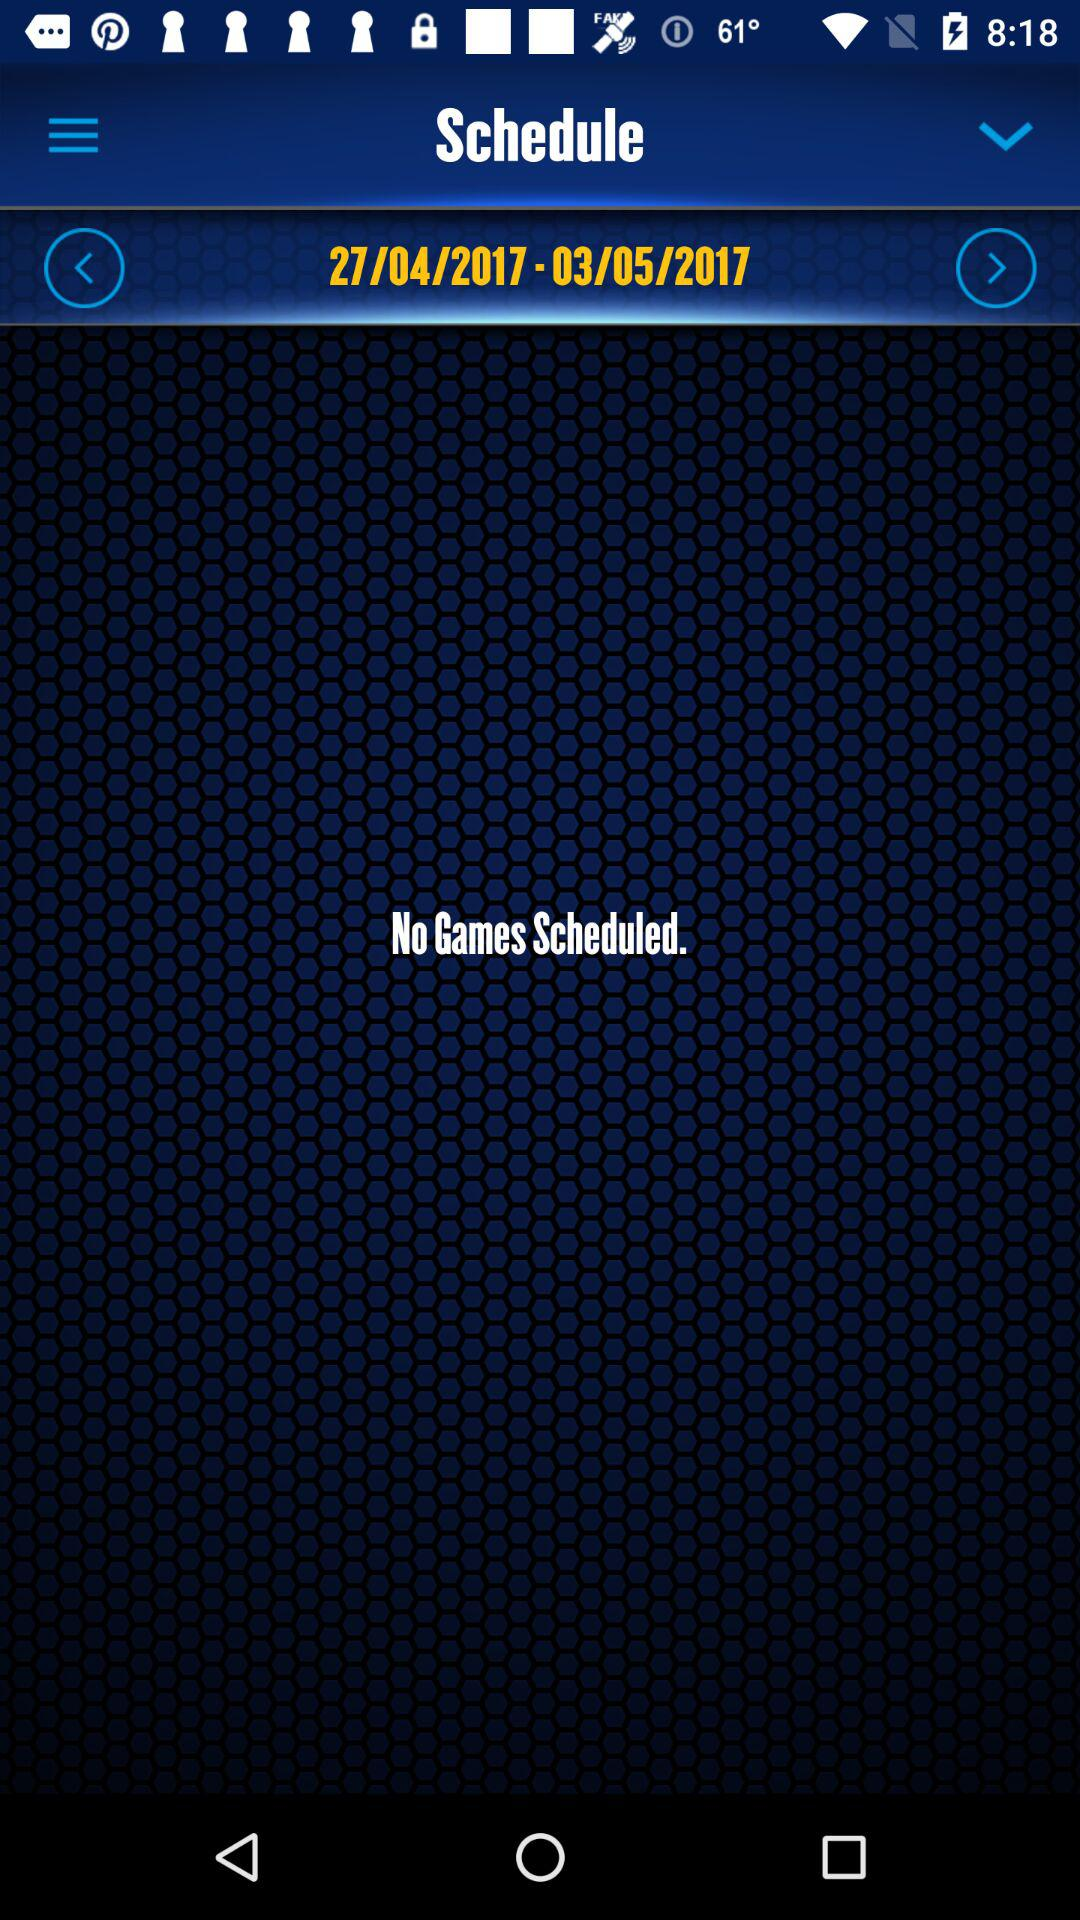Are there any scheduled games? There are no scheduled games. 